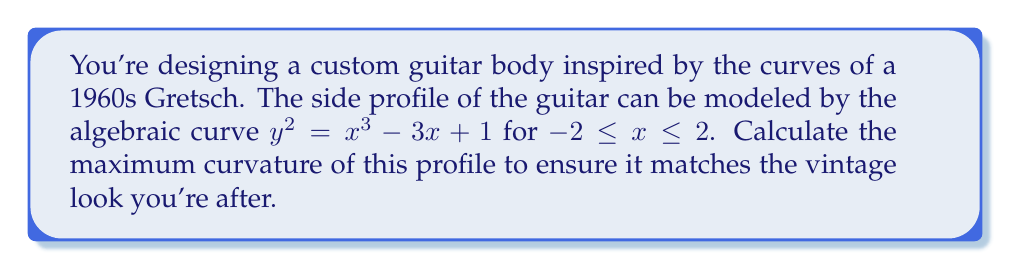Can you solve this math problem? To find the maximum curvature of the guitar body profile, we'll follow these steps:

1) The curvature $\kappa$ of a curve $y = f(x)$ is given by:

   $$\kappa = \frac{|y''|}{(1 + (y')^2)^{3/2}}$$

2) First, we need to find $y'$ and $y''$:
   
   From $y^2 = x^3 - 3x + 1$, we get:
   
   $$2y\frac{dy}{dx} = 3x^2 - 3$$
   
   $$y' = \frac{3x^2 - 3}{2y}$$

3) Differentiating $y'$ again:

   $$y'' = \frac{(6x)(2y) - (3x^2 - 3)(2y')}{4y^2}$$

4) Substituting $y'$ from step 2 into this expression and simplifying:

   $$y'' = \frac{6xy^2 - (3x^2 - 3)(\frac{3x^2 - 3}{2y})}{2y^3}$$

   $$y'' = \frac{12xy^3 - (3x^2 - 3)^2}{4y^4}$$

5) Now we can express the curvature as:

   $$\kappa = \frac{|12xy^3 - (3x^2 - 3)^2|}{4y^4(1 + (\frac{3x^2 - 3}{2y})^2)^{3/2}}$$

6) To find the maximum curvature, we need to find the maximum of this expression for $-2 \leq x \leq 2$. This is a complex expression, so we'll use numerical methods to find the maximum.

7) Using a computer algebra system or graphing calculator, we can plot this function and find its maximum value occurs at approximately $x \approx -1.769$ with a curvature of $\kappa \approx 2.324$.
Answer: $2.324$ (at $x \approx -1.769$) 